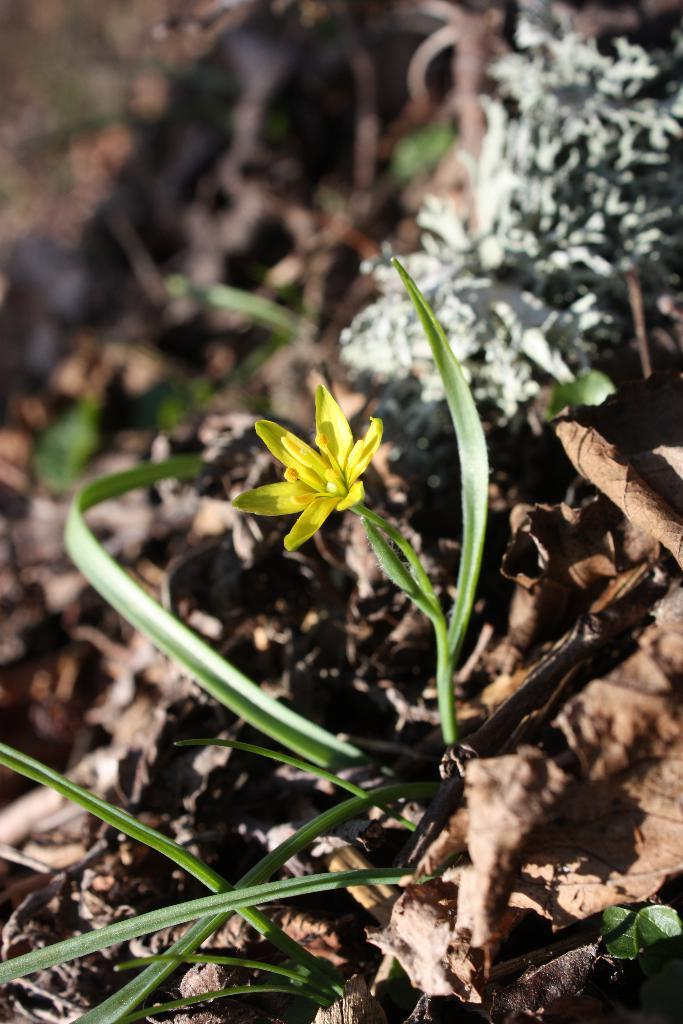What type of natural material can be seen in the image? There are dry leaves in the image. What type of living organisms are present in the image? There are plants and a flower in the image. What is the color of the flower in the image? The flower is yellow in color. Can you hear the band playing in the background of the image? There is no band present in the image, so it is not possible to hear any music. 